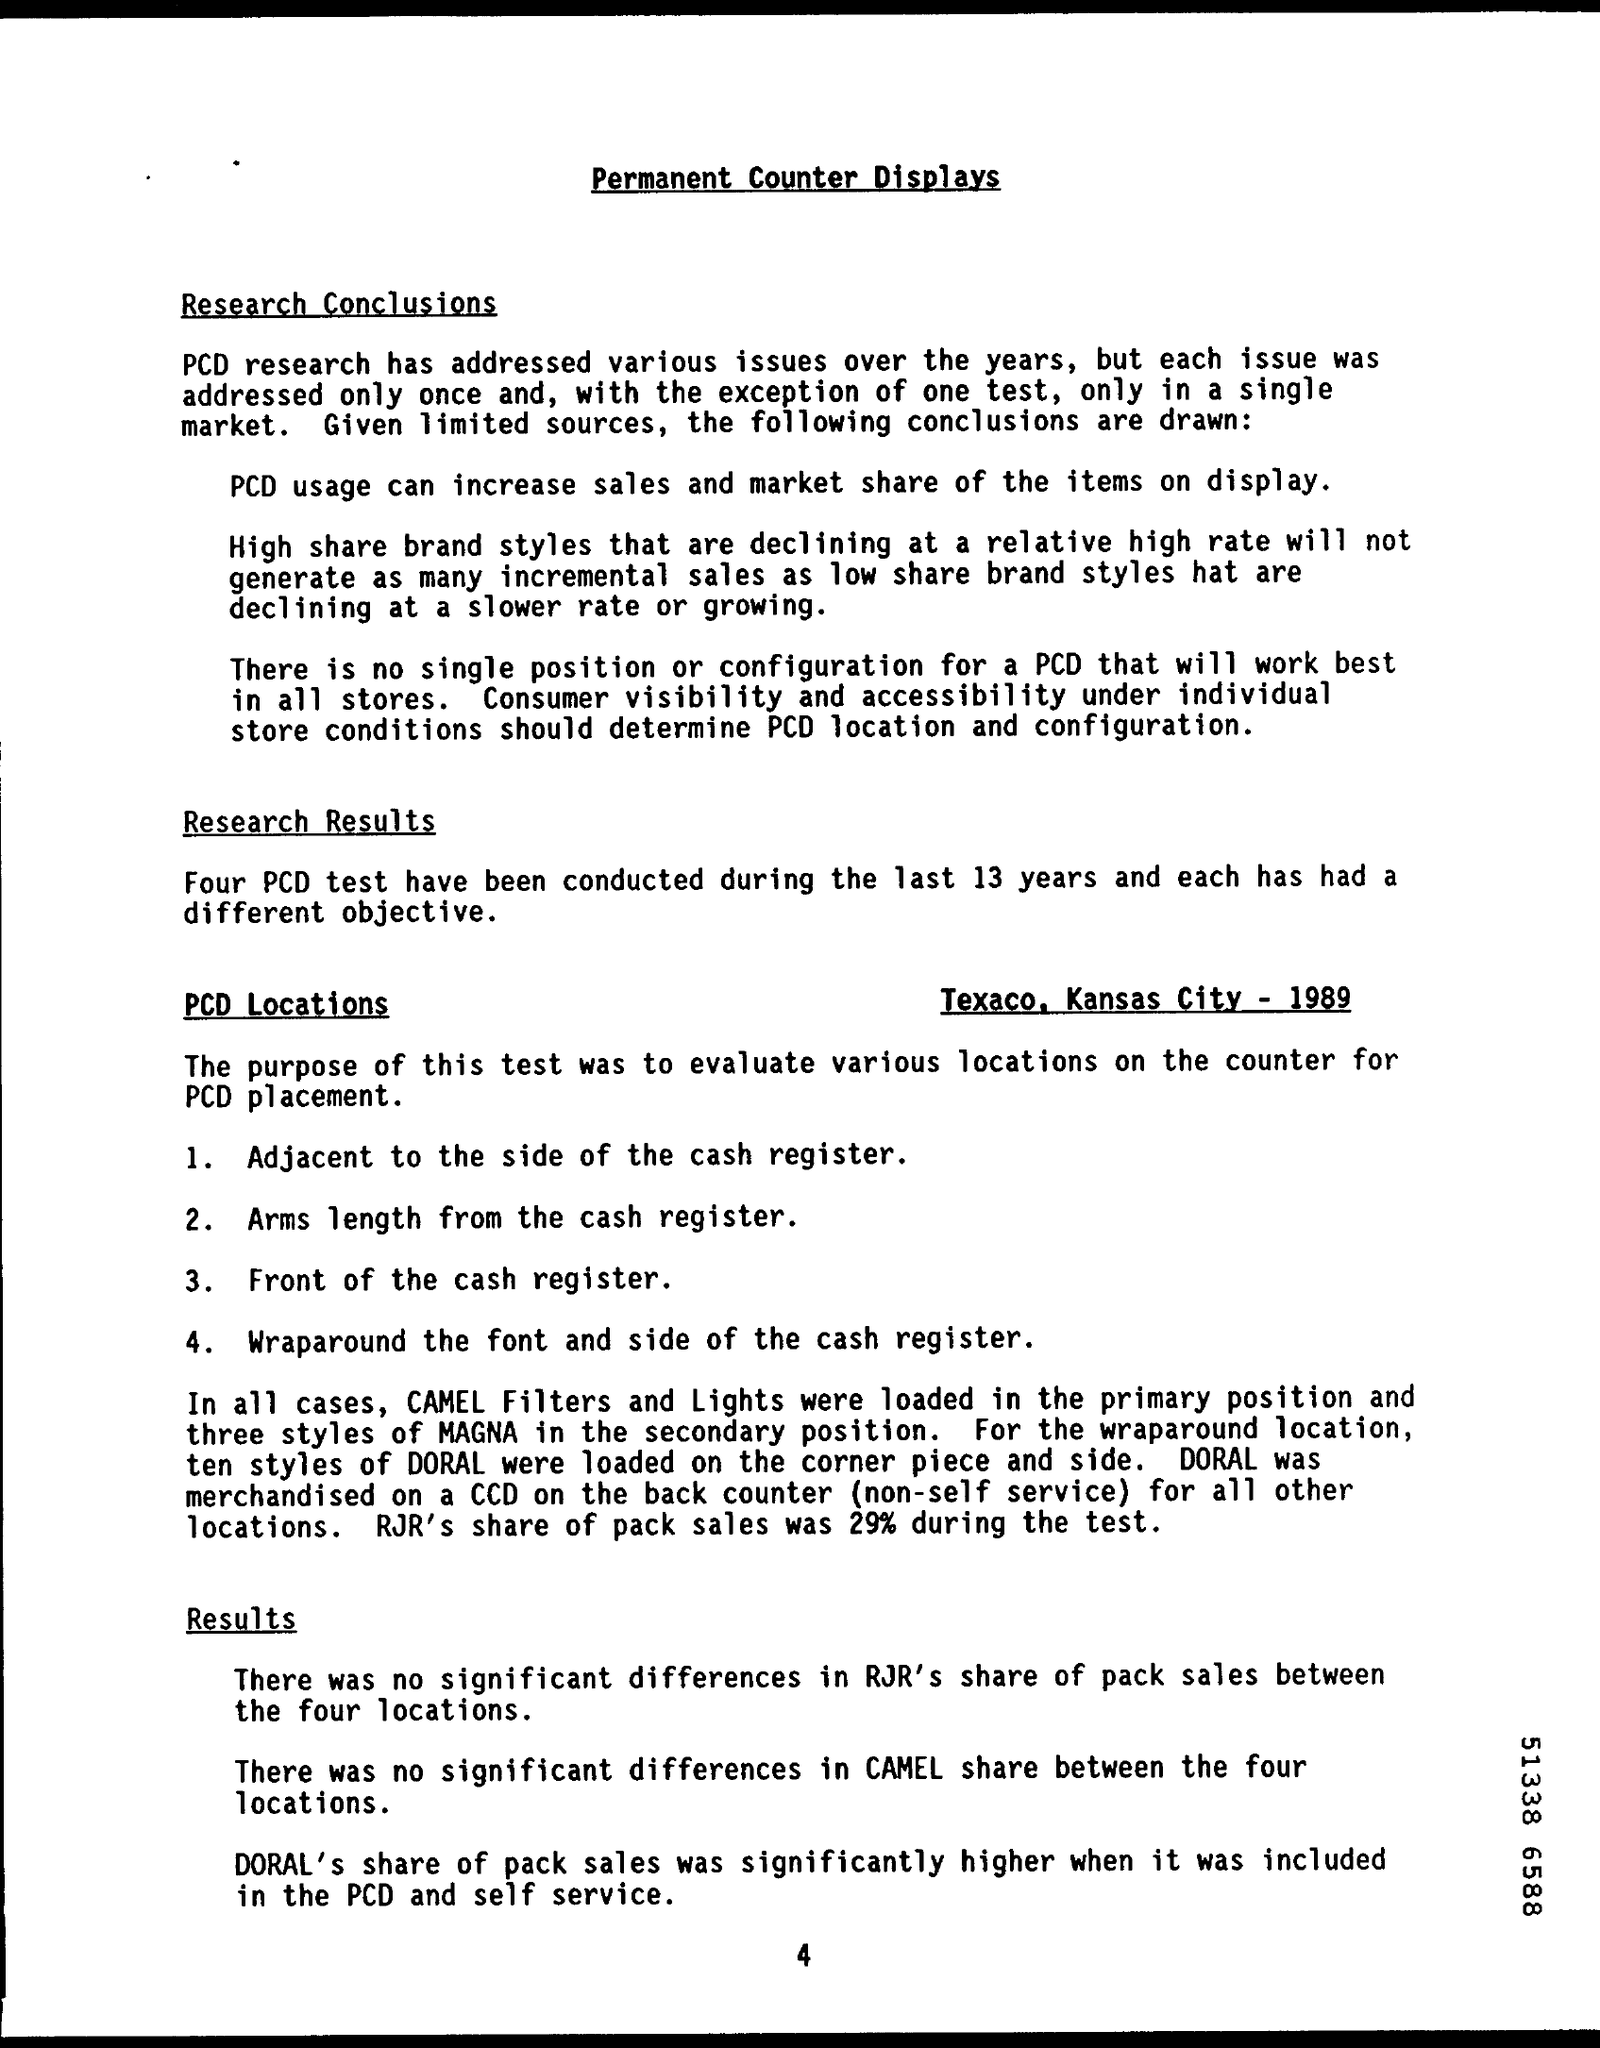Highlight a few significant elements in this photo. The locations of the Petroleum Civil Disturbance (PCD) were Texaco in Kansas City. The title of the document is 'Permanent Counter Displays.' During the last 13 years, four PCD tests have been conducted. During the test, RJR's share of pack sales was 29%. 